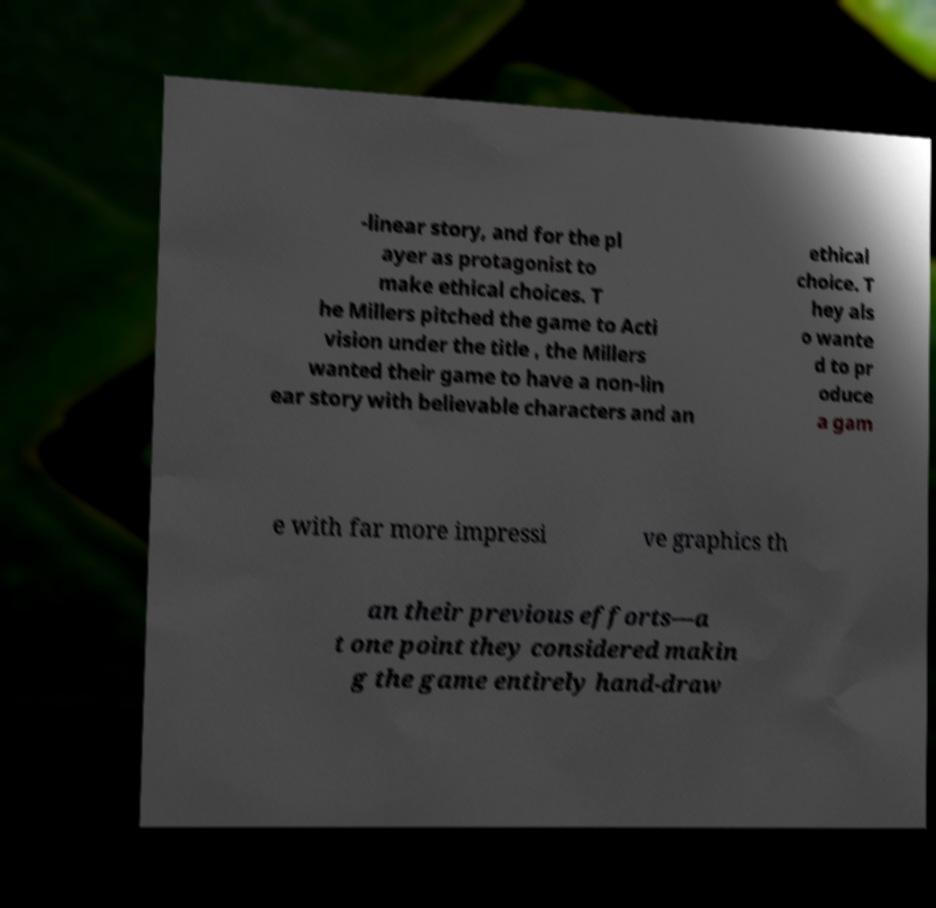I need the written content from this picture converted into text. Can you do that? -linear story, and for the pl ayer as protagonist to make ethical choices. T he Millers pitched the game to Acti vision under the title , the Millers wanted their game to have a non-lin ear story with believable characters and an ethical choice. T hey als o wante d to pr oduce a gam e with far more impressi ve graphics th an their previous efforts—a t one point they considered makin g the game entirely hand-draw 